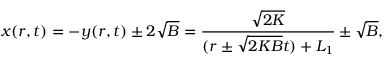Convert formula to latex. <formula><loc_0><loc_0><loc_500><loc_500>x ( r , t ) = - y ( r , t ) \pm 2 \sqrt { B } = \frac { \sqrt { 2 K } } { ( r \pm \sqrt { 2 K B } t ) + L _ { 1 } } \pm \sqrt { B } ,</formula> 